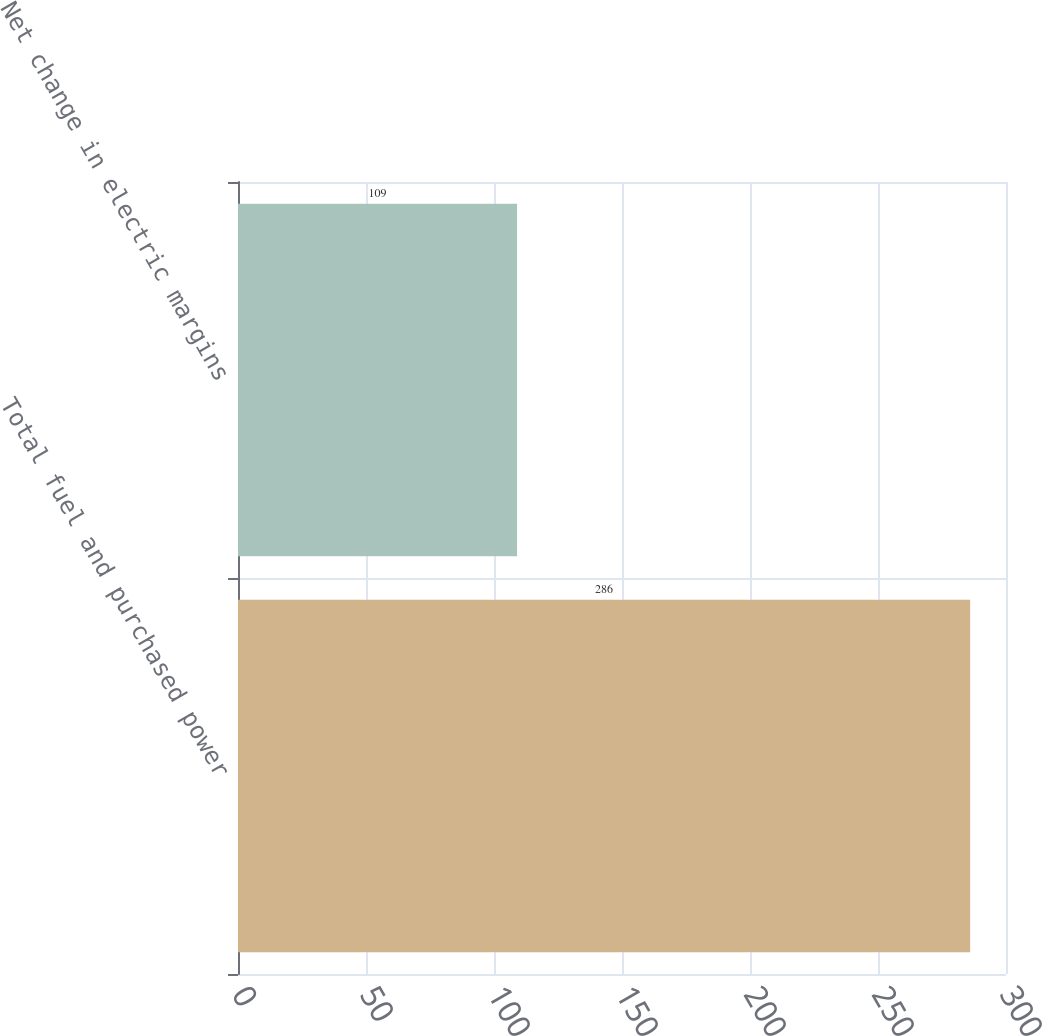<chart> <loc_0><loc_0><loc_500><loc_500><bar_chart><fcel>Total fuel and purchased power<fcel>Net change in electric margins<nl><fcel>286<fcel>109<nl></chart> 